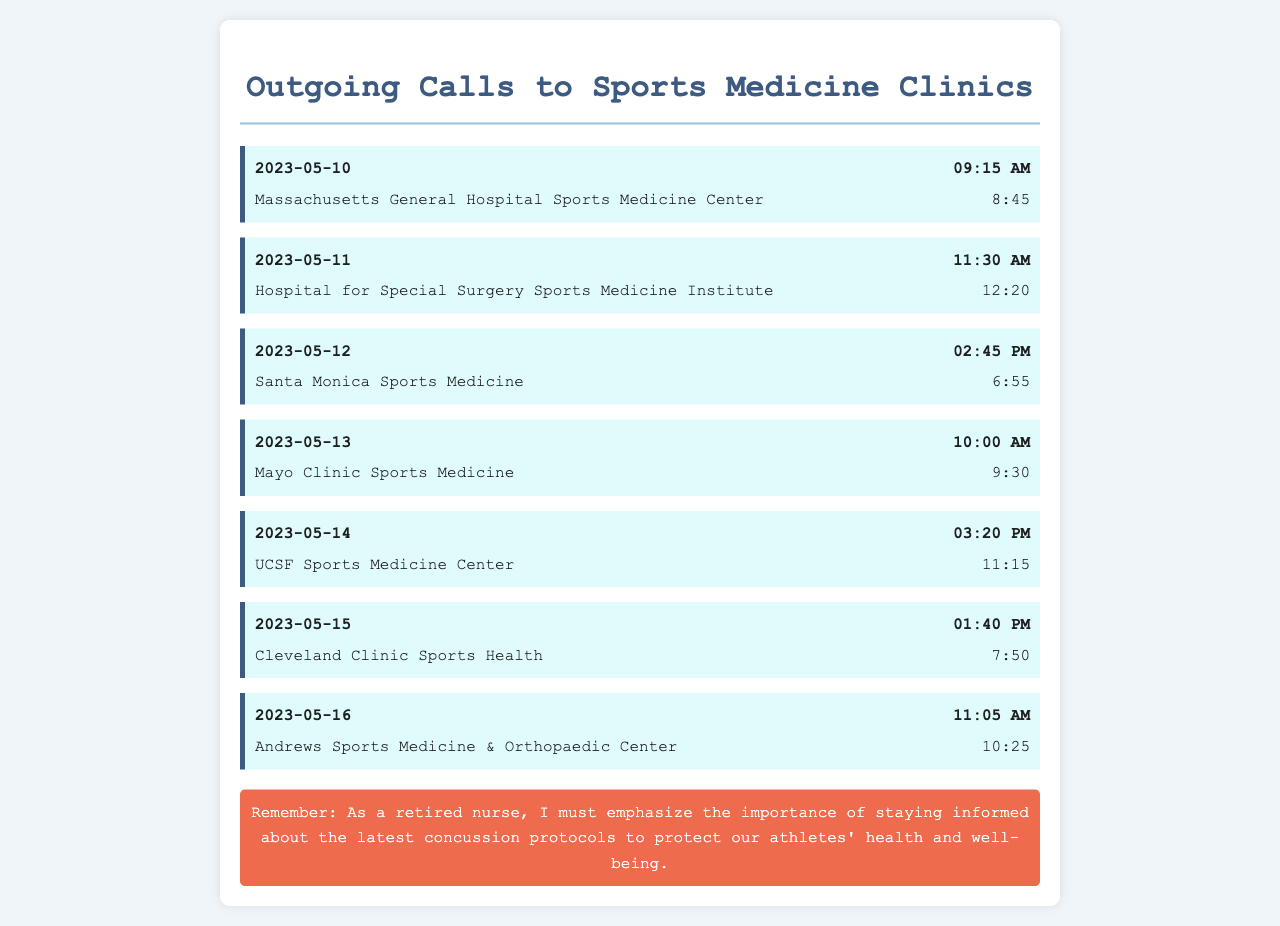what is the date of the first call? The first call in the document is dated May 10, 2023.
Answer: May 10, 2023 what was the duration of the call to UCSF Sports Medicine Center? The call to UCSF Sports Medicine Center lasted for 11 minutes and 15 seconds.
Answer: 11:15 who did the call on May 12, 2023, go to? The call on May 12, 2023, was made to Santa Monica Sports Medicine.
Answer: Santa Monica Sports Medicine how many calls were made in total? The document lists a total of 7 outgoing calls to sports medicine clinics.
Answer: 7 what time was the call made to the Cleveland Clinic Sports Health? The call was made at 1:40 PM on May 15, 2023.
Answer: 1:40 PM which clinic had the longest call duration? The call duration to the Cleveland Clinic Sports Health was the longest at 7 minutes and 50 seconds.
Answer: Cleveland Clinic Sports Health what information are the calls seeking? The calls are seeking updated information on concussion protocols.
Answer: updated information on concussion protocols what is the importance highlighted in the document? The document emphasizes the importance of staying informed about concussion protocols for athlete safety.
Answer: athlete safety 